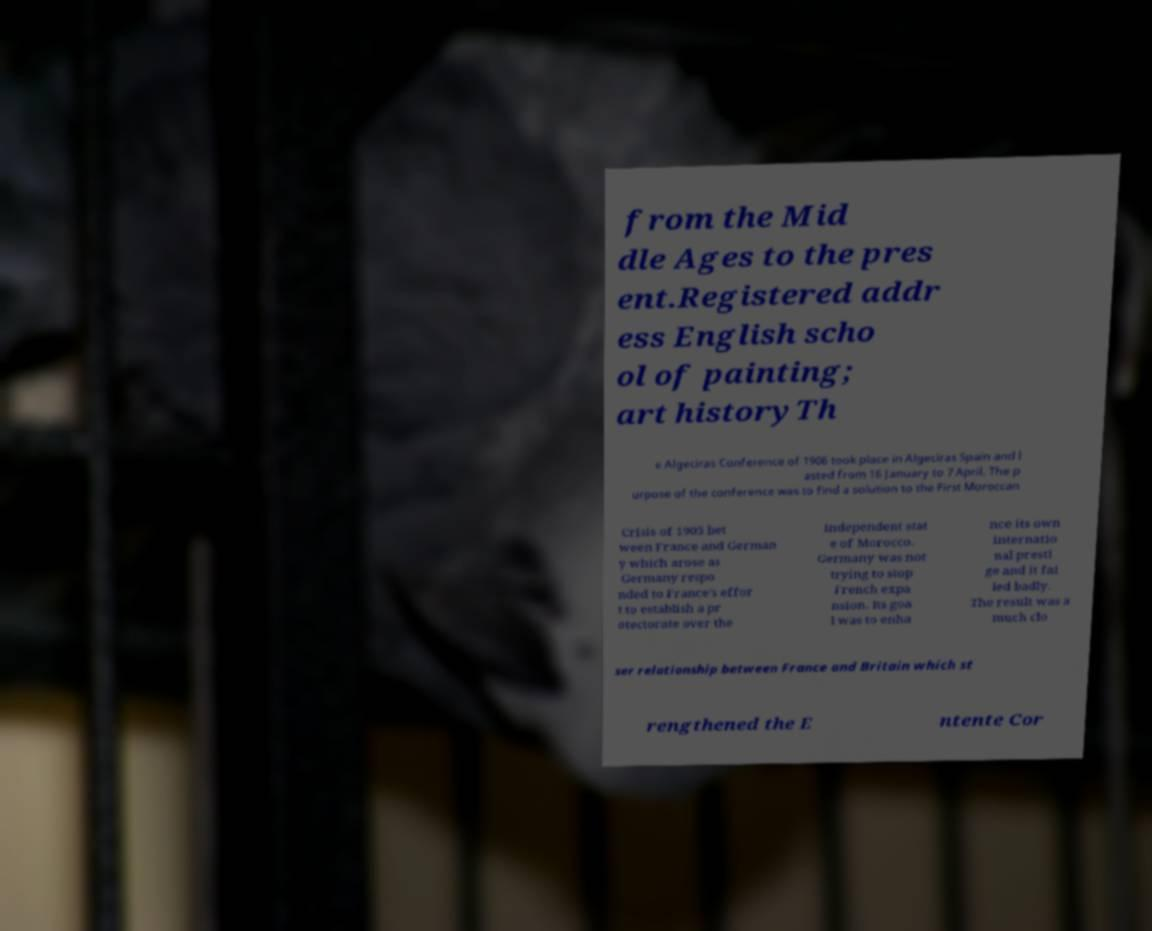I need the written content from this picture converted into text. Can you do that? from the Mid dle Ages to the pres ent.Registered addr ess English scho ol of painting; art historyTh e Algeciras Conference of 1906 took place in Algeciras Spain and l asted from 16 January to 7 April. The p urpose of the conference was to find a solution to the First Moroccan Crisis of 1905 bet ween France and German y which arose as Germany respo nded to France's effor t to establish a pr otectorate over the independent stat e of Morocco. Germany was not trying to stop French expa nsion. Its goa l was to enha nce its own internatio nal presti ge and it fai led badly. The result was a much clo ser relationship between France and Britain which st rengthened the E ntente Cor 